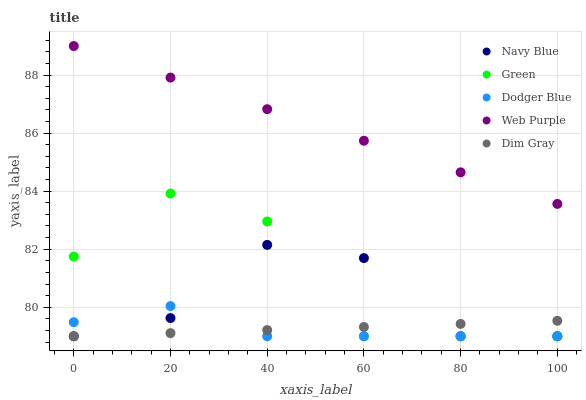Does Dodger Blue have the minimum area under the curve?
Answer yes or no. Yes. Does Web Purple have the maximum area under the curve?
Answer yes or no. Yes. Does Dim Gray have the minimum area under the curve?
Answer yes or no. No. Does Dim Gray have the maximum area under the curve?
Answer yes or no. No. Is Dim Gray the smoothest?
Answer yes or no. Yes. Is Green the roughest?
Answer yes or no. Yes. Is Web Purple the smoothest?
Answer yes or no. No. Is Web Purple the roughest?
Answer yes or no. No. Does Navy Blue have the lowest value?
Answer yes or no. Yes. Does Web Purple have the lowest value?
Answer yes or no. No. Does Web Purple have the highest value?
Answer yes or no. Yes. Does Dim Gray have the highest value?
Answer yes or no. No. Is Navy Blue less than Web Purple?
Answer yes or no. Yes. Is Web Purple greater than Navy Blue?
Answer yes or no. Yes. Does Dodger Blue intersect Green?
Answer yes or no. Yes. Is Dodger Blue less than Green?
Answer yes or no. No. Is Dodger Blue greater than Green?
Answer yes or no. No. Does Navy Blue intersect Web Purple?
Answer yes or no. No. 